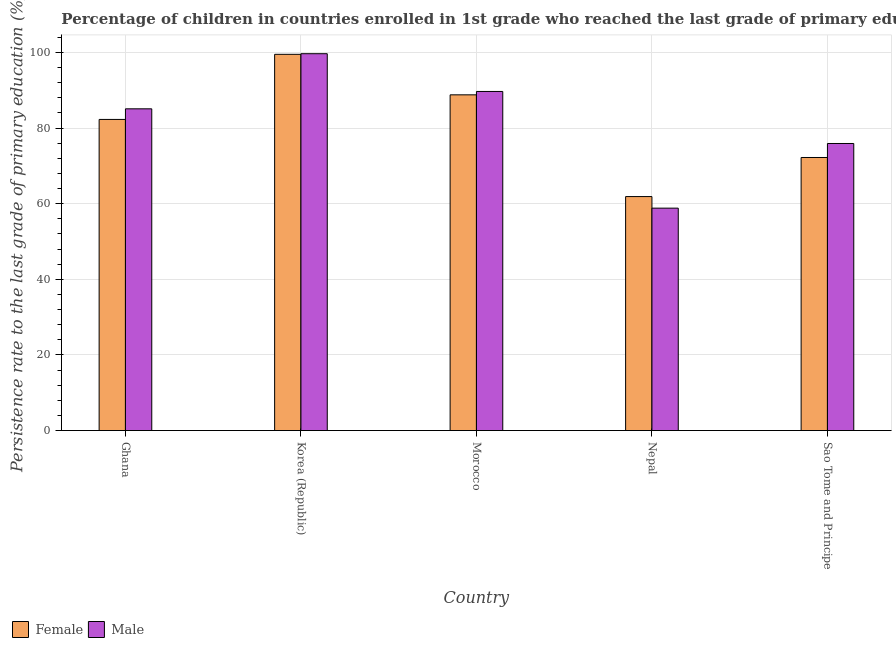How many groups of bars are there?
Your response must be concise. 5. Are the number of bars per tick equal to the number of legend labels?
Offer a terse response. Yes. Are the number of bars on each tick of the X-axis equal?
Your response must be concise. Yes. How many bars are there on the 4th tick from the left?
Provide a succinct answer. 2. How many bars are there on the 1st tick from the right?
Your response must be concise. 2. What is the label of the 3rd group of bars from the left?
Ensure brevity in your answer.  Morocco. In how many cases, is the number of bars for a given country not equal to the number of legend labels?
Offer a terse response. 0. What is the persistence rate of female students in Morocco?
Offer a very short reply. 88.79. Across all countries, what is the maximum persistence rate of male students?
Your answer should be compact. 99.67. Across all countries, what is the minimum persistence rate of male students?
Your answer should be compact. 58.83. In which country was the persistence rate of female students maximum?
Keep it short and to the point. Korea (Republic). In which country was the persistence rate of female students minimum?
Your answer should be compact. Nepal. What is the total persistence rate of male students in the graph?
Give a very brief answer. 409.21. What is the difference between the persistence rate of female students in Korea (Republic) and that in Morocco?
Provide a succinct answer. 10.72. What is the difference between the persistence rate of male students in Sao Tome and Principe and the persistence rate of female students in Nepal?
Keep it short and to the point. 14.04. What is the average persistence rate of male students per country?
Your answer should be compact. 81.84. What is the difference between the persistence rate of female students and persistence rate of male students in Korea (Republic)?
Keep it short and to the point. -0.16. In how many countries, is the persistence rate of female students greater than 76 %?
Make the answer very short. 3. What is the ratio of the persistence rate of female students in Korea (Republic) to that in Nepal?
Ensure brevity in your answer.  1.61. Is the persistence rate of female students in Ghana less than that in Korea (Republic)?
Your answer should be very brief. Yes. What is the difference between the highest and the second highest persistence rate of male students?
Your response must be concise. 9.98. What is the difference between the highest and the lowest persistence rate of male students?
Offer a terse response. 40.84. Are all the bars in the graph horizontal?
Provide a short and direct response. No. What is the difference between two consecutive major ticks on the Y-axis?
Your answer should be very brief. 20. Where does the legend appear in the graph?
Your response must be concise. Bottom left. How are the legend labels stacked?
Your response must be concise. Horizontal. What is the title of the graph?
Offer a terse response. Percentage of children in countries enrolled in 1st grade who reached the last grade of primary education. What is the label or title of the Y-axis?
Offer a terse response. Persistence rate to the last grade of primary education (%). What is the Persistence rate to the last grade of primary education (%) of Female in Ghana?
Provide a succinct answer. 82.29. What is the Persistence rate to the last grade of primary education (%) of Male in Ghana?
Offer a very short reply. 85.1. What is the Persistence rate to the last grade of primary education (%) of Female in Korea (Republic)?
Your answer should be very brief. 99.51. What is the Persistence rate to the last grade of primary education (%) of Male in Korea (Republic)?
Keep it short and to the point. 99.67. What is the Persistence rate to the last grade of primary education (%) in Female in Morocco?
Make the answer very short. 88.79. What is the Persistence rate to the last grade of primary education (%) in Male in Morocco?
Your answer should be very brief. 89.69. What is the Persistence rate to the last grade of primary education (%) in Female in Nepal?
Give a very brief answer. 61.89. What is the Persistence rate to the last grade of primary education (%) of Male in Nepal?
Your answer should be compact. 58.83. What is the Persistence rate to the last grade of primary education (%) of Female in Sao Tome and Principe?
Your response must be concise. 72.22. What is the Persistence rate to the last grade of primary education (%) in Male in Sao Tome and Principe?
Your answer should be compact. 75.93. Across all countries, what is the maximum Persistence rate to the last grade of primary education (%) in Female?
Provide a short and direct response. 99.51. Across all countries, what is the maximum Persistence rate to the last grade of primary education (%) in Male?
Ensure brevity in your answer.  99.67. Across all countries, what is the minimum Persistence rate to the last grade of primary education (%) in Female?
Provide a succinct answer. 61.89. Across all countries, what is the minimum Persistence rate to the last grade of primary education (%) in Male?
Your answer should be very brief. 58.83. What is the total Persistence rate to the last grade of primary education (%) of Female in the graph?
Give a very brief answer. 404.7. What is the total Persistence rate to the last grade of primary education (%) of Male in the graph?
Ensure brevity in your answer.  409.21. What is the difference between the Persistence rate to the last grade of primary education (%) in Female in Ghana and that in Korea (Republic)?
Offer a terse response. -17.22. What is the difference between the Persistence rate to the last grade of primary education (%) of Male in Ghana and that in Korea (Republic)?
Offer a very short reply. -14.57. What is the difference between the Persistence rate to the last grade of primary education (%) in Female in Ghana and that in Morocco?
Make the answer very short. -6.5. What is the difference between the Persistence rate to the last grade of primary education (%) of Male in Ghana and that in Morocco?
Make the answer very short. -4.59. What is the difference between the Persistence rate to the last grade of primary education (%) in Female in Ghana and that in Nepal?
Make the answer very short. 20.4. What is the difference between the Persistence rate to the last grade of primary education (%) of Male in Ghana and that in Nepal?
Offer a terse response. 26.27. What is the difference between the Persistence rate to the last grade of primary education (%) in Female in Ghana and that in Sao Tome and Principe?
Your answer should be very brief. 10.07. What is the difference between the Persistence rate to the last grade of primary education (%) of Male in Ghana and that in Sao Tome and Principe?
Make the answer very short. 9.17. What is the difference between the Persistence rate to the last grade of primary education (%) of Female in Korea (Republic) and that in Morocco?
Offer a terse response. 10.72. What is the difference between the Persistence rate to the last grade of primary education (%) in Male in Korea (Republic) and that in Morocco?
Offer a very short reply. 9.98. What is the difference between the Persistence rate to the last grade of primary education (%) of Female in Korea (Republic) and that in Nepal?
Offer a terse response. 37.62. What is the difference between the Persistence rate to the last grade of primary education (%) of Male in Korea (Republic) and that in Nepal?
Ensure brevity in your answer.  40.84. What is the difference between the Persistence rate to the last grade of primary education (%) of Female in Korea (Republic) and that in Sao Tome and Principe?
Give a very brief answer. 27.29. What is the difference between the Persistence rate to the last grade of primary education (%) in Male in Korea (Republic) and that in Sao Tome and Principe?
Ensure brevity in your answer.  23.74. What is the difference between the Persistence rate to the last grade of primary education (%) of Female in Morocco and that in Nepal?
Your response must be concise. 26.9. What is the difference between the Persistence rate to the last grade of primary education (%) in Male in Morocco and that in Nepal?
Give a very brief answer. 30.86. What is the difference between the Persistence rate to the last grade of primary education (%) in Female in Morocco and that in Sao Tome and Principe?
Your answer should be compact. 16.57. What is the difference between the Persistence rate to the last grade of primary education (%) in Male in Morocco and that in Sao Tome and Principe?
Your answer should be very brief. 13.76. What is the difference between the Persistence rate to the last grade of primary education (%) of Female in Nepal and that in Sao Tome and Principe?
Keep it short and to the point. -10.33. What is the difference between the Persistence rate to the last grade of primary education (%) of Male in Nepal and that in Sao Tome and Principe?
Make the answer very short. -17.1. What is the difference between the Persistence rate to the last grade of primary education (%) in Female in Ghana and the Persistence rate to the last grade of primary education (%) in Male in Korea (Republic)?
Offer a very short reply. -17.38. What is the difference between the Persistence rate to the last grade of primary education (%) of Female in Ghana and the Persistence rate to the last grade of primary education (%) of Male in Morocco?
Offer a terse response. -7.4. What is the difference between the Persistence rate to the last grade of primary education (%) in Female in Ghana and the Persistence rate to the last grade of primary education (%) in Male in Nepal?
Provide a short and direct response. 23.46. What is the difference between the Persistence rate to the last grade of primary education (%) in Female in Ghana and the Persistence rate to the last grade of primary education (%) in Male in Sao Tome and Principe?
Keep it short and to the point. 6.36. What is the difference between the Persistence rate to the last grade of primary education (%) of Female in Korea (Republic) and the Persistence rate to the last grade of primary education (%) of Male in Morocco?
Offer a very short reply. 9.82. What is the difference between the Persistence rate to the last grade of primary education (%) of Female in Korea (Republic) and the Persistence rate to the last grade of primary education (%) of Male in Nepal?
Ensure brevity in your answer.  40.68. What is the difference between the Persistence rate to the last grade of primary education (%) in Female in Korea (Republic) and the Persistence rate to the last grade of primary education (%) in Male in Sao Tome and Principe?
Your answer should be compact. 23.58. What is the difference between the Persistence rate to the last grade of primary education (%) in Female in Morocco and the Persistence rate to the last grade of primary education (%) in Male in Nepal?
Your answer should be very brief. 29.97. What is the difference between the Persistence rate to the last grade of primary education (%) in Female in Morocco and the Persistence rate to the last grade of primary education (%) in Male in Sao Tome and Principe?
Give a very brief answer. 12.87. What is the difference between the Persistence rate to the last grade of primary education (%) in Female in Nepal and the Persistence rate to the last grade of primary education (%) in Male in Sao Tome and Principe?
Keep it short and to the point. -14.04. What is the average Persistence rate to the last grade of primary education (%) of Female per country?
Provide a short and direct response. 80.94. What is the average Persistence rate to the last grade of primary education (%) in Male per country?
Make the answer very short. 81.84. What is the difference between the Persistence rate to the last grade of primary education (%) of Female and Persistence rate to the last grade of primary education (%) of Male in Ghana?
Your answer should be very brief. -2.81. What is the difference between the Persistence rate to the last grade of primary education (%) in Female and Persistence rate to the last grade of primary education (%) in Male in Korea (Republic)?
Provide a short and direct response. -0.16. What is the difference between the Persistence rate to the last grade of primary education (%) in Female and Persistence rate to the last grade of primary education (%) in Male in Morocco?
Make the answer very short. -0.9. What is the difference between the Persistence rate to the last grade of primary education (%) in Female and Persistence rate to the last grade of primary education (%) in Male in Nepal?
Offer a very short reply. 3.06. What is the difference between the Persistence rate to the last grade of primary education (%) in Female and Persistence rate to the last grade of primary education (%) in Male in Sao Tome and Principe?
Make the answer very short. -3.71. What is the ratio of the Persistence rate to the last grade of primary education (%) of Female in Ghana to that in Korea (Republic)?
Your response must be concise. 0.83. What is the ratio of the Persistence rate to the last grade of primary education (%) of Male in Ghana to that in Korea (Republic)?
Your response must be concise. 0.85. What is the ratio of the Persistence rate to the last grade of primary education (%) of Female in Ghana to that in Morocco?
Provide a short and direct response. 0.93. What is the ratio of the Persistence rate to the last grade of primary education (%) of Male in Ghana to that in Morocco?
Your response must be concise. 0.95. What is the ratio of the Persistence rate to the last grade of primary education (%) in Female in Ghana to that in Nepal?
Offer a terse response. 1.33. What is the ratio of the Persistence rate to the last grade of primary education (%) in Male in Ghana to that in Nepal?
Offer a terse response. 1.45. What is the ratio of the Persistence rate to the last grade of primary education (%) of Female in Ghana to that in Sao Tome and Principe?
Ensure brevity in your answer.  1.14. What is the ratio of the Persistence rate to the last grade of primary education (%) in Male in Ghana to that in Sao Tome and Principe?
Keep it short and to the point. 1.12. What is the ratio of the Persistence rate to the last grade of primary education (%) in Female in Korea (Republic) to that in Morocco?
Give a very brief answer. 1.12. What is the ratio of the Persistence rate to the last grade of primary education (%) of Male in Korea (Republic) to that in Morocco?
Your answer should be very brief. 1.11. What is the ratio of the Persistence rate to the last grade of primary education (%) in Female in Korea (Republic) to that in Nepal?
Make the answer very short. 1.61. What is the ratio of the Persistence rate to the last grade of primary education (%) of Male in Korea (Republic) to that in Nepal?
Provide a succinct answer. 1.69. What is the ratio of the Persistence rate to the last grade of primary education (%) of Female in Korea (Republic) to that in Sao Tome and Principe?
Offer a terse response. 1.38. What is the ratio of the Persistence rate to the last grade of primary education (%) in Male in Korea (Republic) to that in Sao Tome and Principe?
Offer a terse response. 1.31. What is the ratio of the Persistence rate to the last grade of primary education (%) in Female in Morocco to that in Nepal?
Offer a very short reply. 1.43. What is the ratio of the Persistence rate to the last grade of primary education (%) in Male in Morocco to that in Nepal?
Your answer should be compact. 1.52. What is the ratio of the Persistence rate to the last grade of primary education (%) of Female in Morocco to that in Sao Tome and Principe?
Give a very brief answer. 1.23. What is the ratio of the Persistence rate to the last grade of primary education (%) in Male in Morocco to that in Sao Tome and Principe?
Give a very brief answer. 1.18. What is the ratio of the Persistence rate to the last grade of primary education (%) in Female in Nepal to that in Sao Tome and Principe?
Make the answer very short. 0.86. What is the ratio of the Persistence rate to the last grade of primary education (%) of Male in Nepal to that in Sao Tome and Principe?
Provide a succinct answer. 0.77. What is the difference between the highest and the second highest Persistence rate to the last grade of primary education (%) in Female?
Provide a succinct answer. 10.72. What is the difference between the highest and the second highest Persistence rate to the last grade of primary education (%) in Male?
Make the answer very short. 9.98. What is the difference between the highest and the lowest Persistence rate to the last grade of primary education (%) of Female?
Offer a terse response. 37.62. What is the difference between the highest and the lowest Persistence rate to the last grade of primary education (%) in Male?
Give a very brief answer. 40.84. 